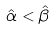<formula> <loc_0><loc_0><loc_500><loc_500>\hat { \alpha } < \hat { \beta }</formula> 